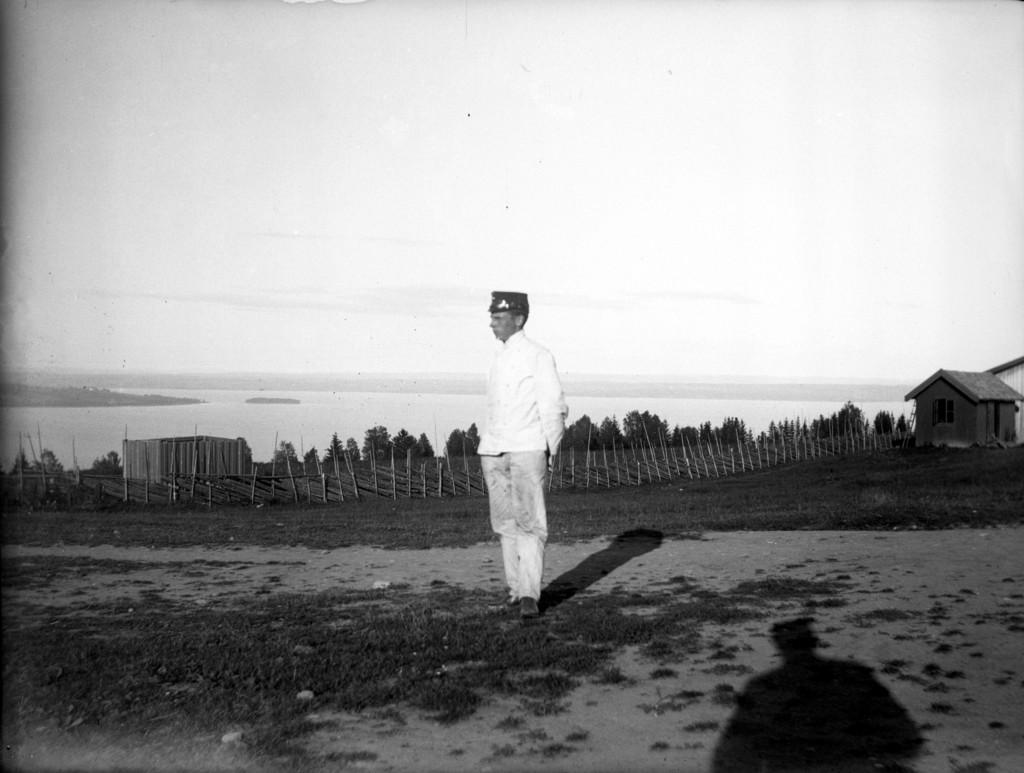What is the main subject of the image? There is a person standing in the image. What type of natural environment is visible in the image? There are trees in the image. What type of architectural feature can be seen in the image? There is fencing in the image. What type of building is present in the image? There is a house in the image. What type of landscape feature is visible in the image? There is water visible in the image. What part of the natural environment is visible in the image? The sky is visible in the image. What type of bubble can be seen floating in the image? There is no bubble present in the image. What type of nut is being cracked by the person in the image? There is no nut-cracking activity depicted in the image. 